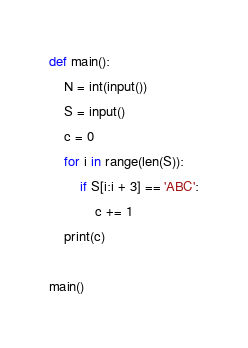<code> <loc_0><loc_0><loc_500><loc_500><_Python_>def main():
    N = int(input())
    S = input()
    c = 0
    for i in range(len(S)):
        if S[i:i + 3] == 'ABC':
            c += 1
    print(c)

main()
</code> 